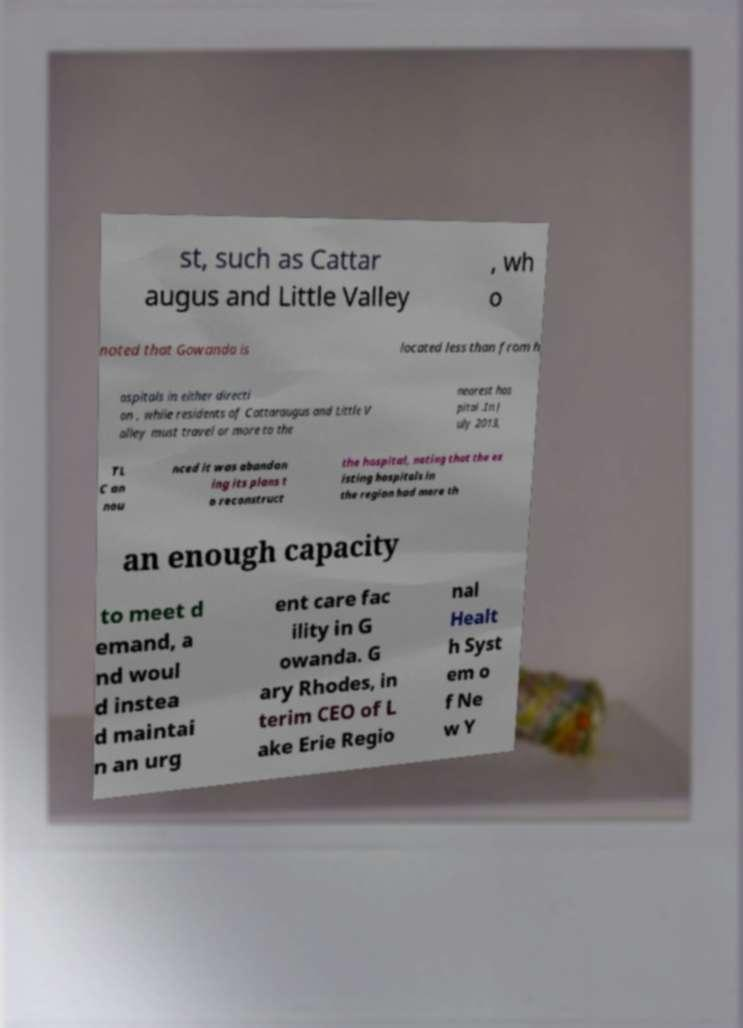Can you accurately transcribe the text from the provided image for me? st, such as Cattar augus and Little Valley , wh o noted that Gowanda is located less than from h ospitals in either directi on , while residents of Cattaraugus and Little V alley must travel or more to the nearest hos pital .In J uly 2013, TL C an nou nced it was abandon ing its plans t o reconstruct the hospital, noting that the ex isting hospitals in the region had more th an enough capacity to meet d emand, a nd woul d instea d maintai n an urg ent care fac ility in G owanda. G ary Rhodes, in terim CEO of L ake Erie Regio nal Healt h Syst em o f Ne w Y 